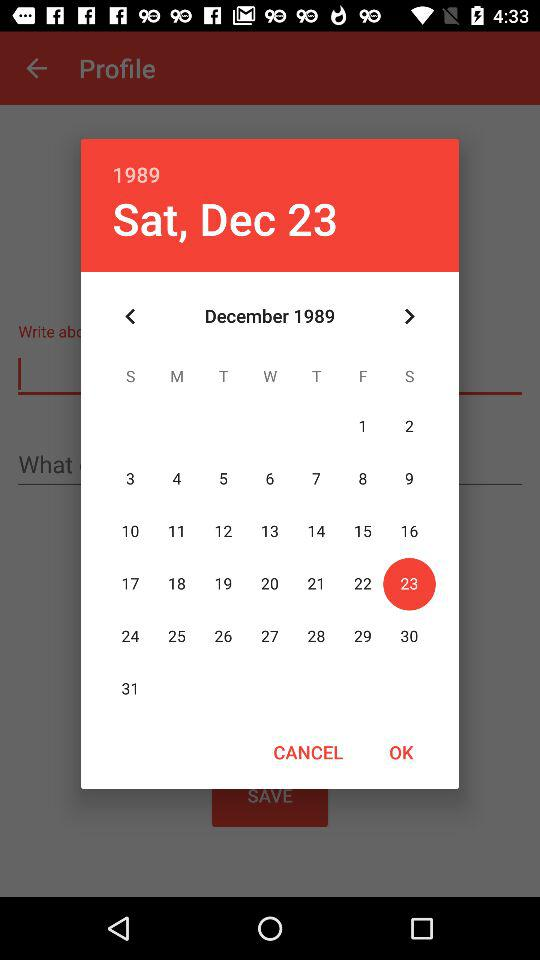Which date is selected on the calendar? The selected date on the calendar is Saturday, December 23, 1989. 